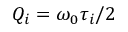<formula> <loc_0><loc_0><loc_500><loc_500>Q _ { i } = \omega _ { 0 } \tau _ { i } / 2</formula> 